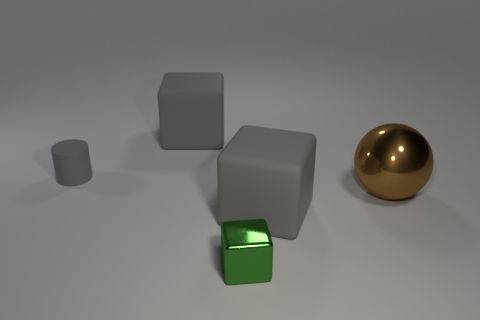Does the small metal thing have the same shape as the big brown metallic object?
Provide a succinct answer. No. How many things are cubes that are in front of the small gray matte object or gray cylinders?
Ensure brevity in your answer.  3. Is there another brown metallic thing of the same shape as the large shiny thing?
Your answer should be compact. No. Are there an equal number of brown spheres on the right side of the big brown object and small green things?
Give a very brief answer. No. What number of objects are the same size as the cylinder?
Provide a short and direct response. 1. What number of matte cylinders are behind the metallic ball?
Provide a succinct answer. 1. What material is the big thing that is behind the large brown shiny sphere behind the small green metallic thing made of?
Offer a terse response. Rubber. Is there a small metal cube of the same color as the tiny cylinder?
Your answer should be very brief. No. There is a green thing that is the same material as the big brown sphere; what is its size?
Your response must be concise. Small. Is there any other thing that is the same color as the metallic ball?
Give a very brief answer. No. 